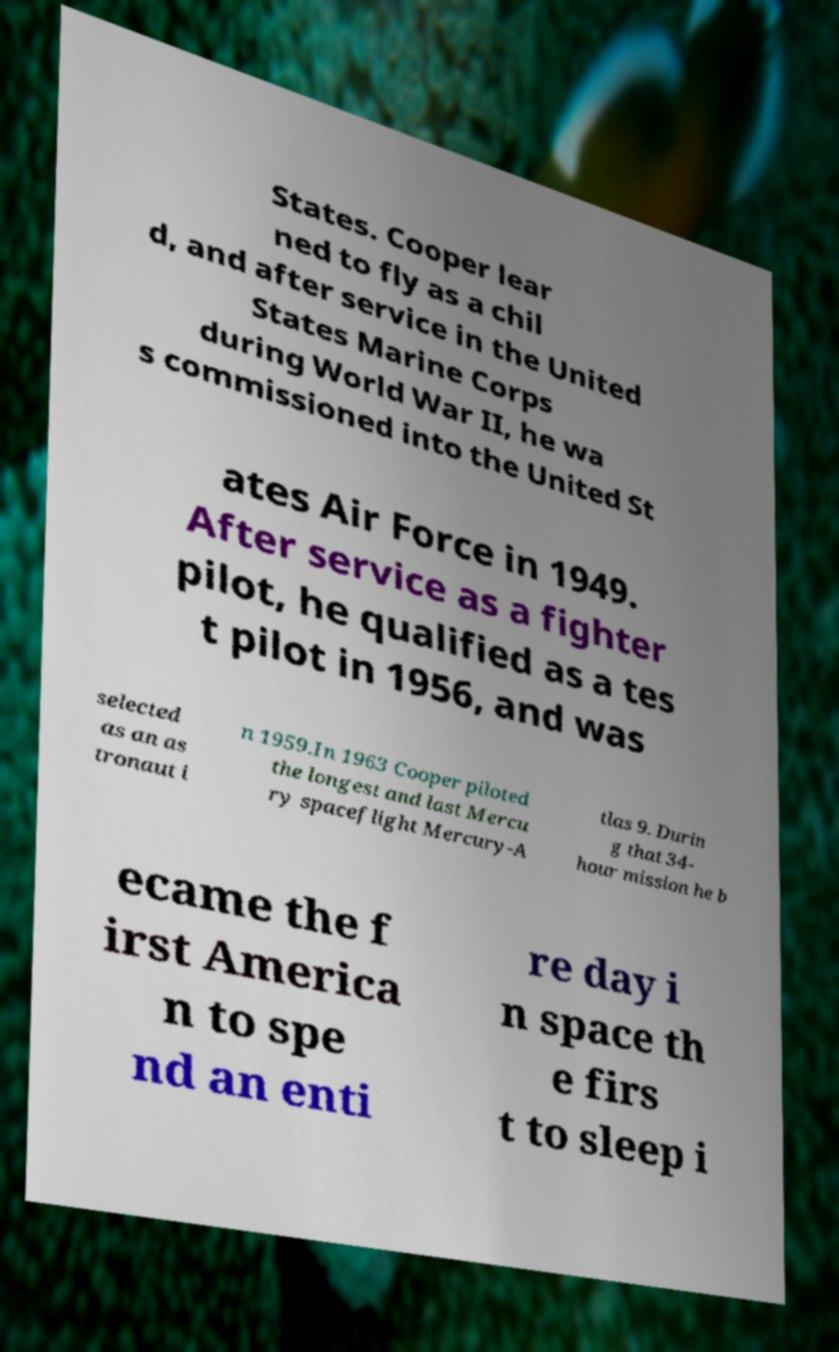Could you assist in decoding the text presented in this image and type it out clearly? States. Cooper lear ned to fly as a chil d, and after service in the United States Marine Corps during World War II, he wa s commissioned into the United St ates Air Force in 1949. After service as a fighter pilot, he qualified as a tes t pilot in 1956, and was selected as an as tronaut i n 1959.In 1963 Cooper piloted the longest and last Mercu ry spaceflight Mercury-A tlas 9. Durin g that 34- hour mission he b ecame the f irst America n to spe nd an enti re day i n space th e firs t to sleep i 